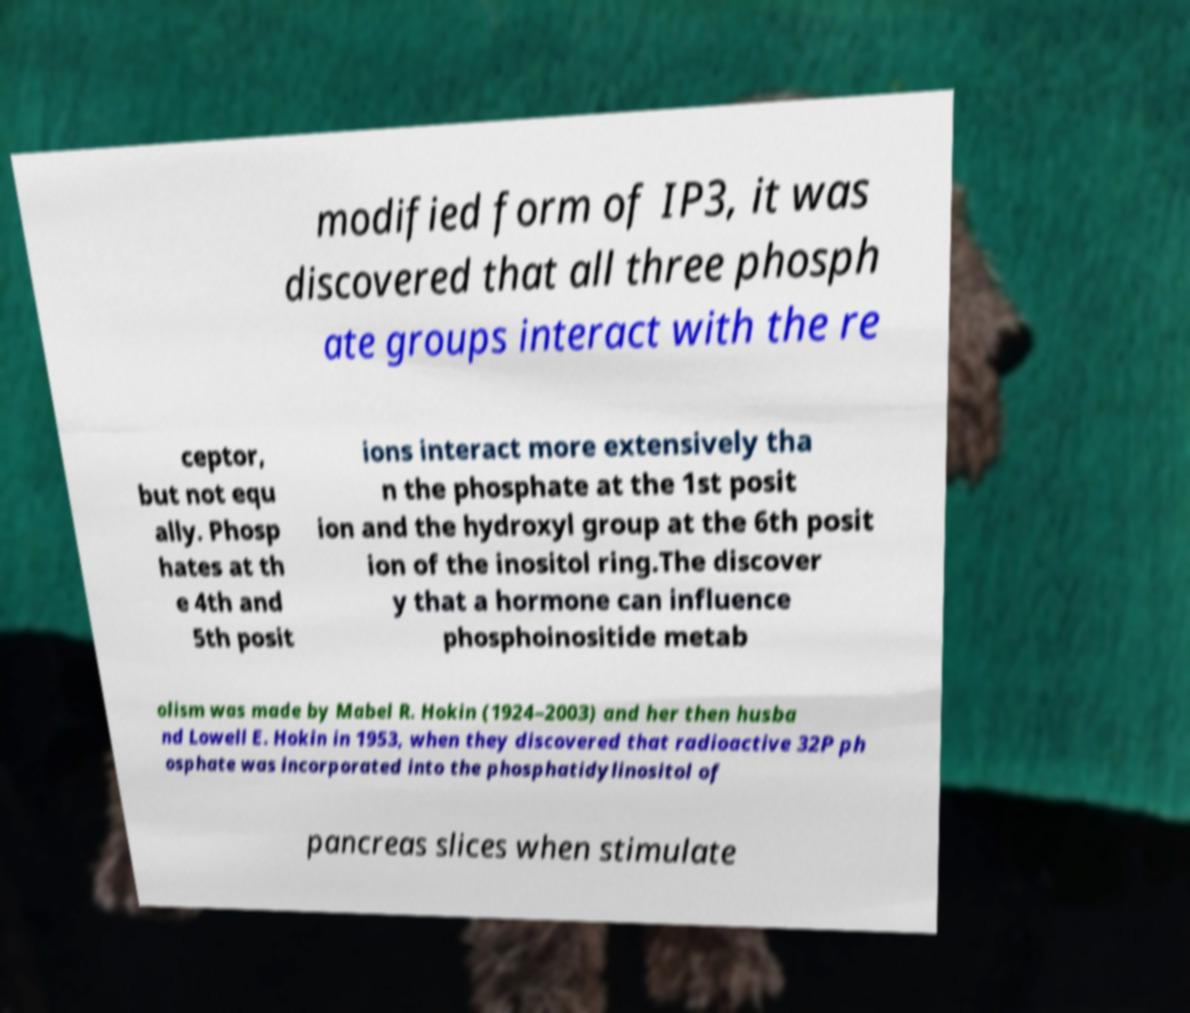Can you read and provide the text displayed in the image?This photo seems to have some interesting text. Can you extract and type it out for me? modified form of IP3, it was discovered that all three phosph ate groups interact with the re ceptor, but not equ ally. Phosp hates at th e 4th and 5th posit ions interact more extensively tha n the phosphate at the 1st posit ion and the hydroxyl group at the 6th posit ion of the inositol ring.The discover y that a hormone can influence phosphoinositide metab olism was made by Mabel R. Hokin (1924–2003) and her then husba nd Lowell E. Hokin in 1953, when they discovered that radioactive 32P ph osphate was incorporated into the phosphatidylinositol of pancreas slices when stimulate 